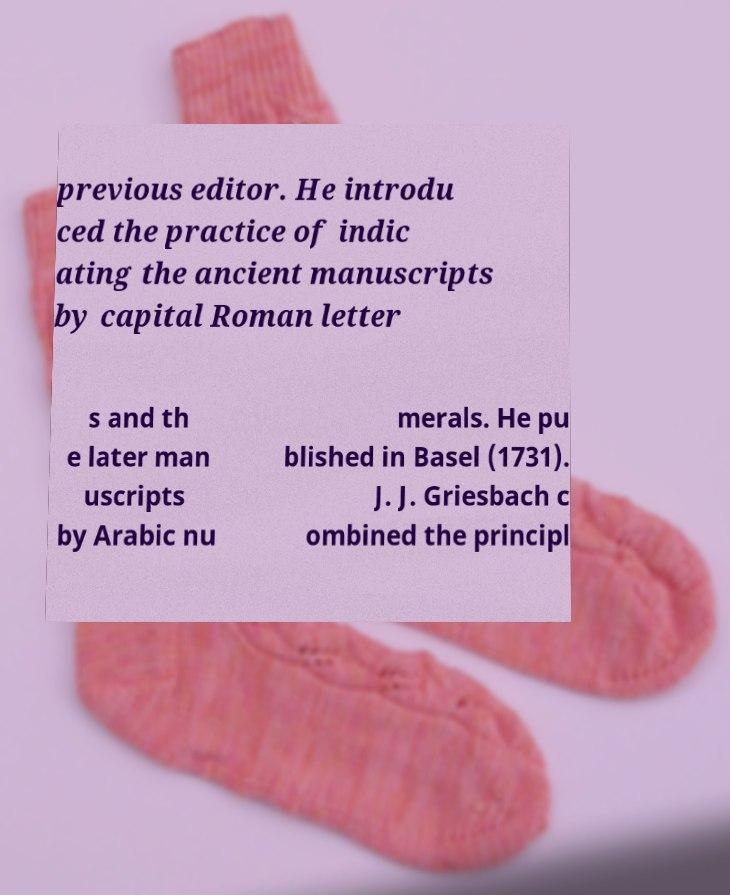Please read and relay the text visible in this image. What does it say? previous editor. He introdu ced the practice of indic ating the ancient manuscripts by capital Roman letter s and th e later man uscripts by Arabic nu merals. He pu blished in Basel (1731). J. J. Griesbach c ombined the principl 